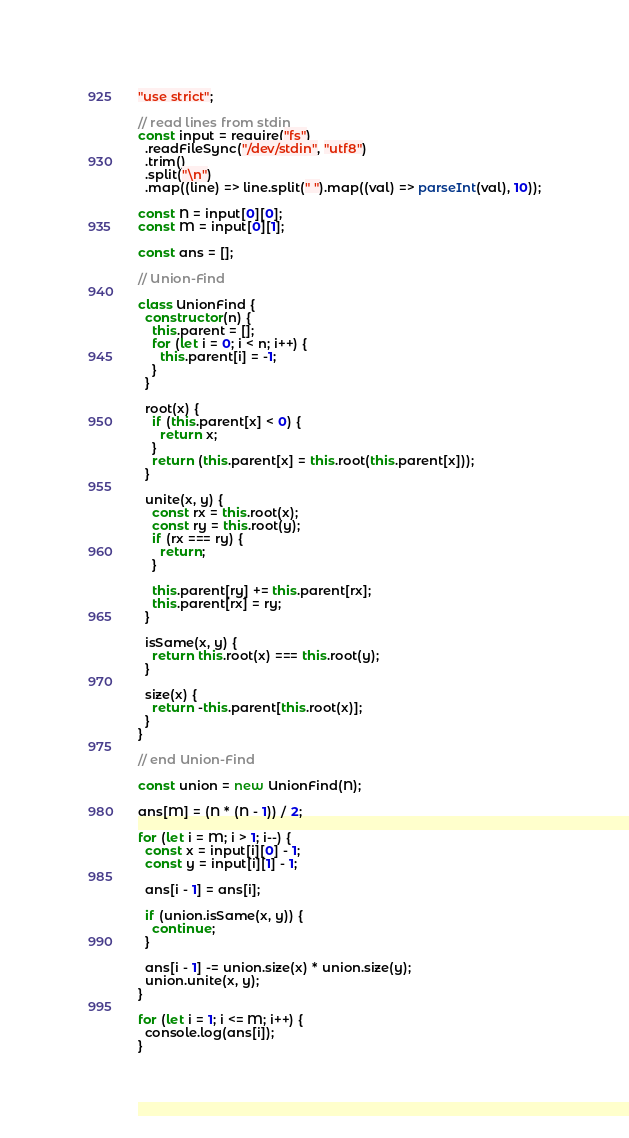Convert code to text. <code><loc_0><loc_0><loc_500><loc_500><_JavaScript_>"use strict";

// read lines from stdin
const input = require("fs")
  .readFileSync("/dev/stdin", "utf8")
  .trim()
  .split("\n")
  .map((line) => line.split(" ").map((val) => parseInt(val), 10));

const N = input[0][0];
const M = input[0][1];

const ans = [];

// Union-Find

class UnionFind {
  constructor(n) {
    this.parent = [];
    for (let i = 0; i < n; i++) {
      this.parent[i] = -1;
    }
  }

  root(x) {
    if (this.parent[x] < 0) {
      return x;
    }
    return (this.parent[x] = this.root(this.parent[x]));
  }

  unite(x, y) {
    const rx = this.root(x);
    const ry = this.root(y);
    if (rx === ry) {
      return;
    }

    this.parent[ry] += this.parent[rx];
    this.parent[rx] = ry;
  }

  isSame(x, y) {
    return this.root(x) === this.root(y);
  }

  size(x) {
    return -this.parent[this.root(x)];
  }
}

// end Union-Find

const union = new UnionFind(N);

ans[M] = (N * (N - 1)) / 2;

for (let i = M; i > 1; i--) {
  const x = input[i][0] - 1;
  const y = input[i][1] - 1;

  ans[i - 1] = ans[i];

  if (union.isSame(x, y)) {
    continue;
  }

  ans[i - 1] -= union.size(x) * union.size(y);
  union.unite(x, y);
}

for (let i = 1; i <= M; i++) {
  console.log(ans[i]);
}
</code> 